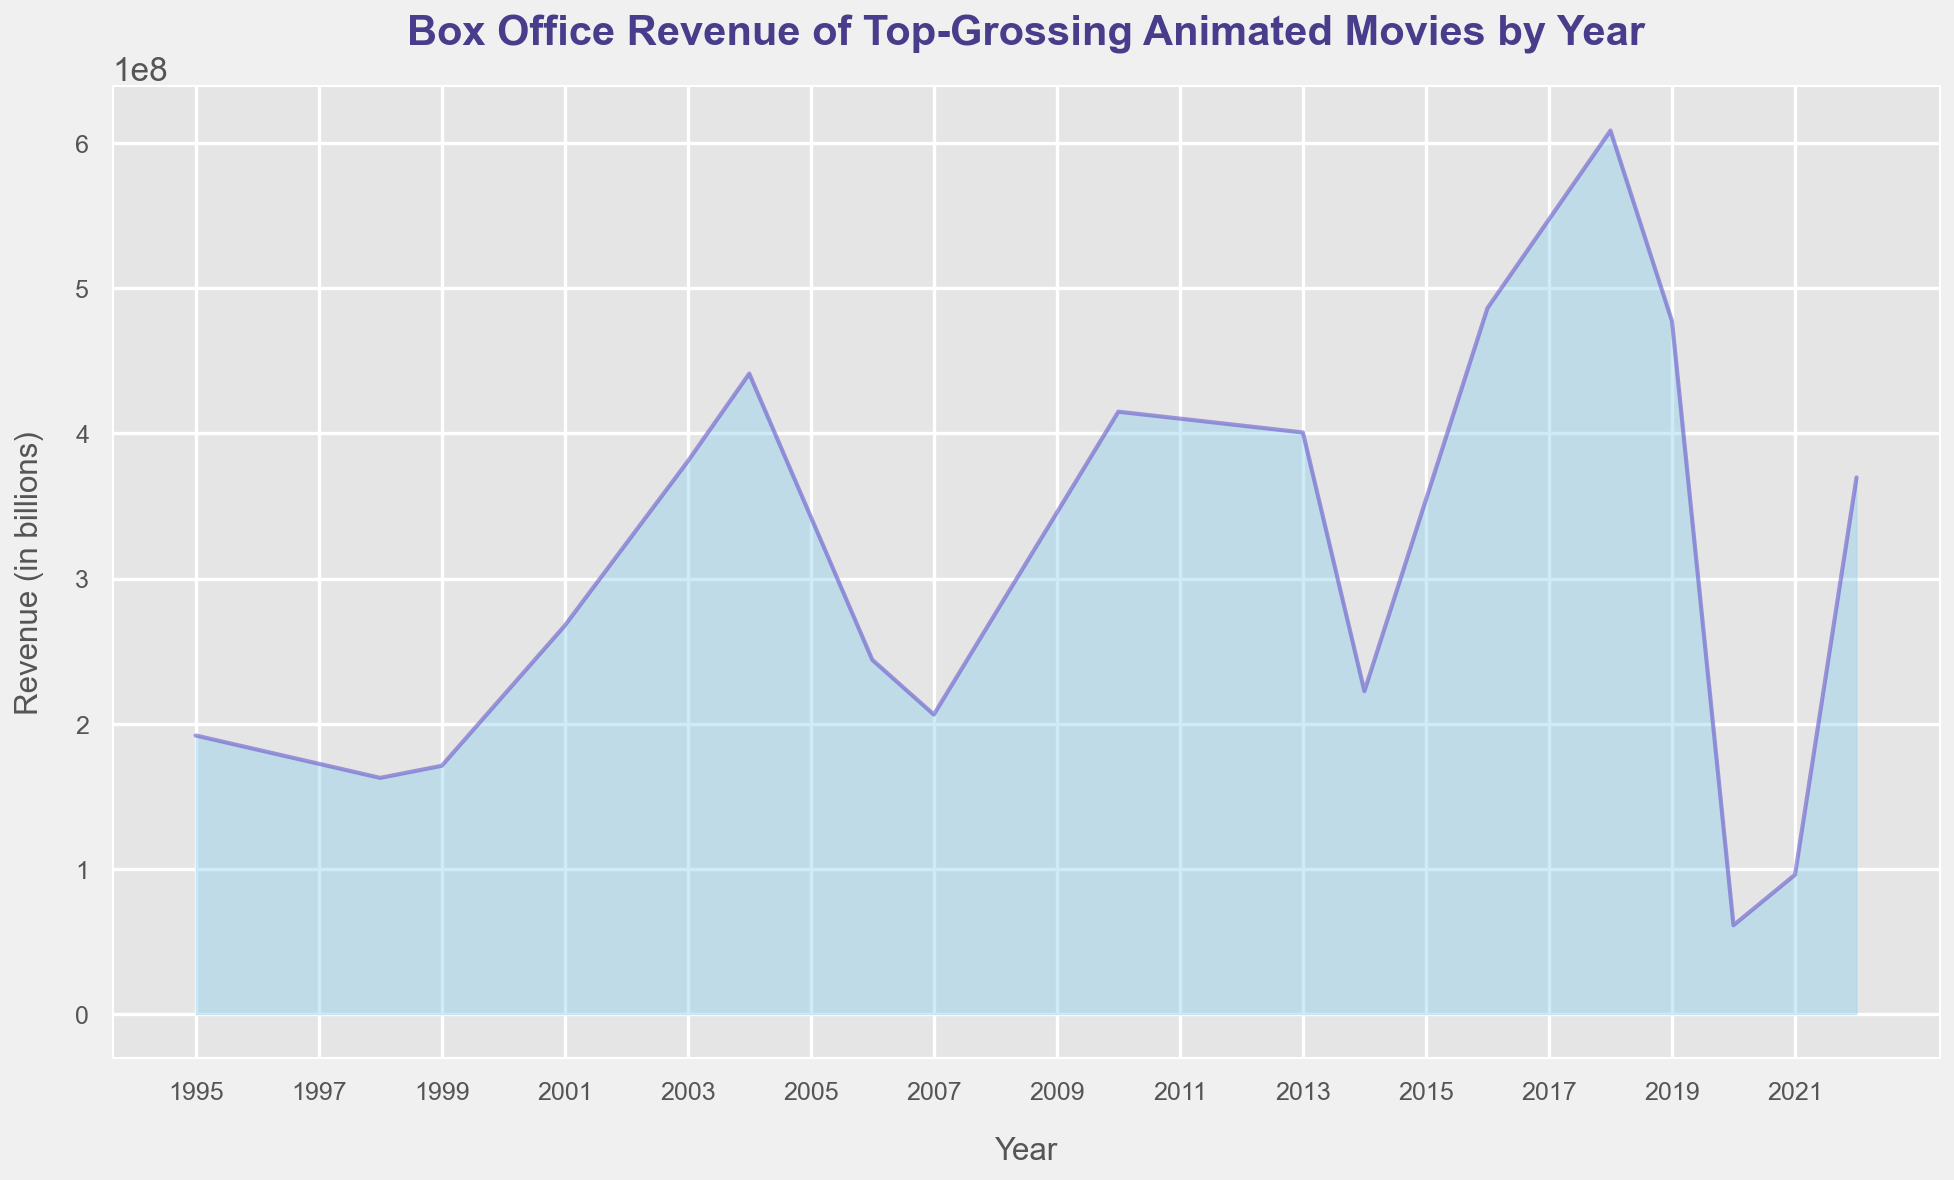Which movie had the highest box office revenue? To find the movie with the highest box office revenue, look at the peak value in the area chart. The tallest peak corresponds to the movie with the highest revenue.
Answer: Incredibles 2 What is the total revenue for the movies released from 2010 to 2014? Sum the revenues for the movies released in the years 2010, 2013, and 2014: Toy Story 3 (415000000), Frozen (400700000), and Big Hero 6 (222500000). Add these values together. 415000000 + 400700000 + 222500000 = 1038200000
Answer: 1038200000 Which year had the lowest box office revenue? Look for the shortest point on the area chart, which corresponds to the year with the lowest revenue.
Answer: 2020 What is the average box office revenue for the movies released between 2001 and 2007, inclusive? Calculate the average by adding the revenues for Shrek (267600000), Finding Nemo (380800000), Shrek 2 (441200000), Cars (244100000), and Ratatouille (206400000) and then dividing by the number of movies (5). (267600000 + 380800000 + 441200000 + 244100000 + 206400000) / 5 = 308020000
Answer: 308020000 Is the box office revenue for Frozen II greater than or less than the revenue for Shrek 2? Compare the revenue values for Frozen II (477400000) and Shrek 2 (441200000). Determine which is higher.
Answer: Greater than How has the trend in box office revenue changed from 2001 to 2022? Observe the gradual changes in the area chart from 2001 to 2022. Look for increases, decreases, and the general shape of the curve across these years. The trend shows generally increasing revenues with significant spikes and dips at certain points.
Answer: Generally increasing Which had higher revenue, Toy Story 3 or Finding Dory? Compare the revenue values for Toy Story 3 (415000000) and Finding Dory (486300000). Determine which is higher.
Answer: Finding Dory What is the difference in box office revenue between 1995 and 2010? Calculate the difference between the revenues for Toy Story (1995, 192000000) and Toy Story 3 (2010, 415000000). 415000000 - 192000000 = 223000000
Answer: 223000000 What year had the highest increase in box office revenue compared to the previous top year? Identify the largest jump between two peaks in the area chart by comparing each year to its previous top year. The largest jump is between 2018 (608600000) and 2004 (441200000). Calculate the difference: 608600000 - 441200000 = 167400000.
Answer: 2018 How does the revenue for Onward (2020) compare to the first movie in the chart, Toy Story (1995)? Compare the revenue values for Onward (61300000) and Toy Story (192000000).
Answer: Less than 